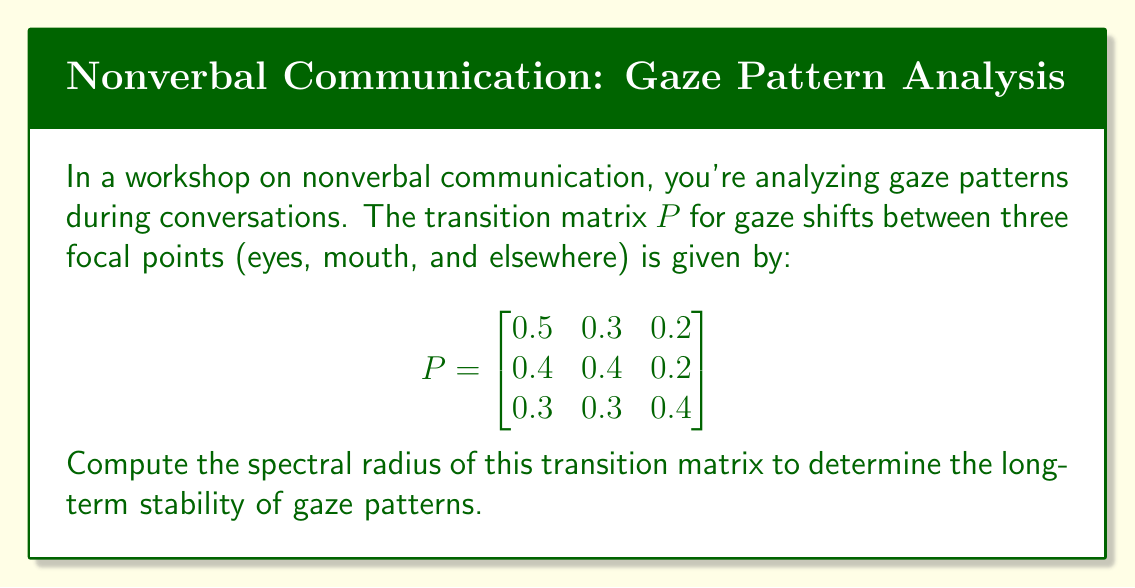What is the answer to this math problem? To find the spectral radius of the transition matrix $P$, we need to follow these steps:

1) First, calculate the characteristic polynomial of $P$:
   $\det(P - \lambda I) = 0$

   $$\begin{vmatrix}
   0.5-\lambda & 0.3 & 0.2 \\
   0.4 & 0.4-\lambda & 0.2 \\
   0.3 & 0.3 & 0.4-\lambda
   \end{vmatrix} = 0$$

2) Expand the determinant:
   $(0.5-\lambda)[(0.4-\lambda)(0.4-\lambda)-0.06] - 0.3[0.4(0.4-\lambda)-0.06] + 0.2[0.12-0.3(0.4-\lambda)] = 0$

3) Simplify:
   $-\lambda^3 + 1.3\lambda^2 - 0.44\lambda + 0.048 = 0$

4) The roots of this polynomial are the eigenvalues of $P$. We can use a numerical method or computer algebra system to find them:
   $\lambda_1 = 1$
   $\lambda_2 \approx 0.2054$
   $\lambda_3 \approx 0.0946$

5) The spectral radius is the maximum absolute value of the eigenvalues:
   $\rho(P) = \max\{|\lambda_1|, |\lambda_2|, |\lambda_3|\} = \max\{1, 0.2054, 0.0946\} = 1$

The spectral radius being 1 indicates that the gaze pattern distribution will converge to a stable equilibrium in the long term, which is typical for stochastic matrices.
Answer: $\rho(P) = 1$ 